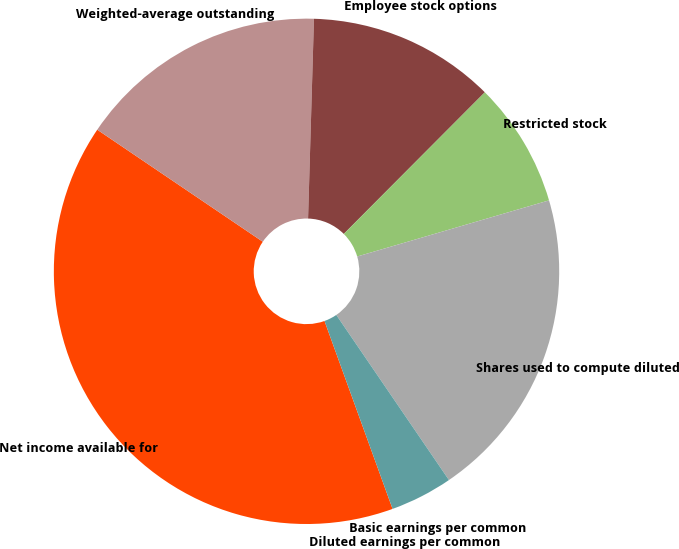<chart> <loc_0><loc_0><loc_500><loc_500><pie_chart><fcel>Net income available for<fcel>Weighted-average outstanding<fcel>Employee stock options<fcel>Restricted stock<fcel>Shares used to compute diluted<fcel>Basic earnings per common<fcel>Diluted earnings per common<nl><fcel>40.0%<fcel>16.0%<fcel>12.0%<fcel>8.0%<fcel>20.0%<fcel>4.0%<fcel>0.0%<nl></chart> 